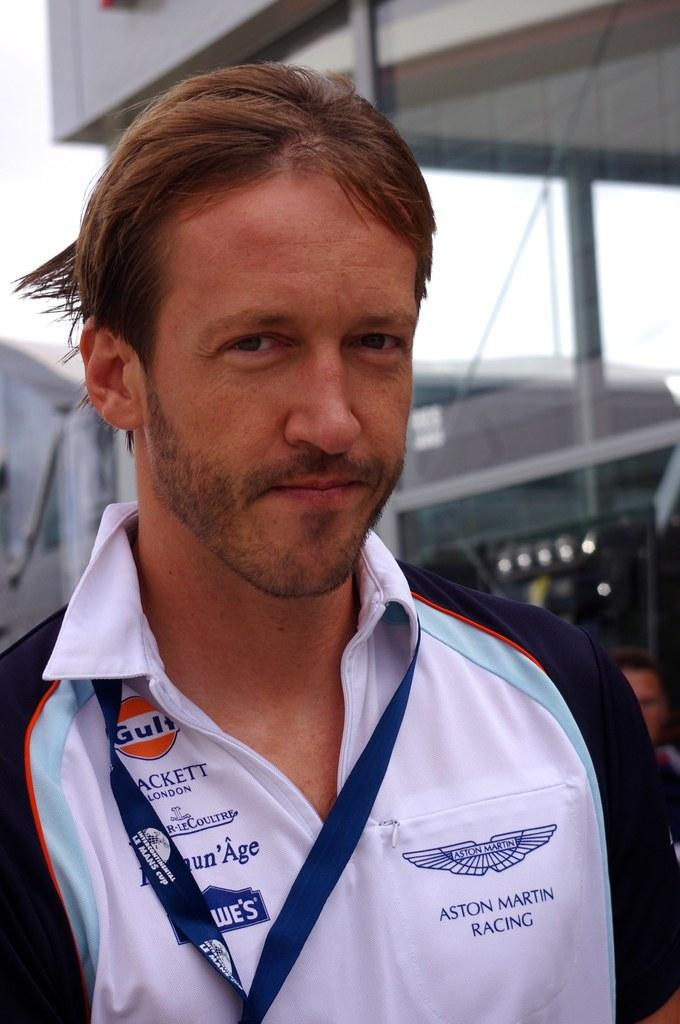<image>
Provide a brief description of the given image. A man wearing an Aston Martin racing shirt. 